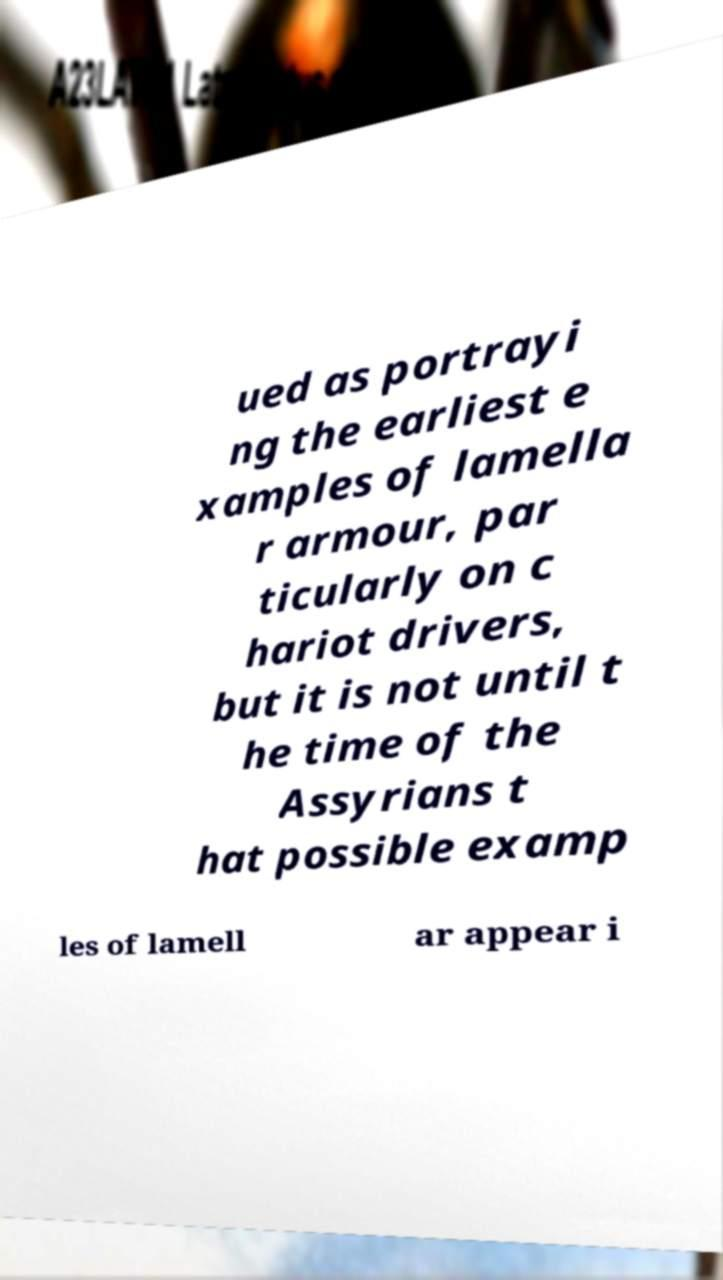Could you extract and type out the text from this image? ued as portrayi ng the earliest e xamples of lamella r armour, par ticularly on c hariot drivers, but it is not until t he time of the Assyrians t hat possible examp les of lamell ar appear i 